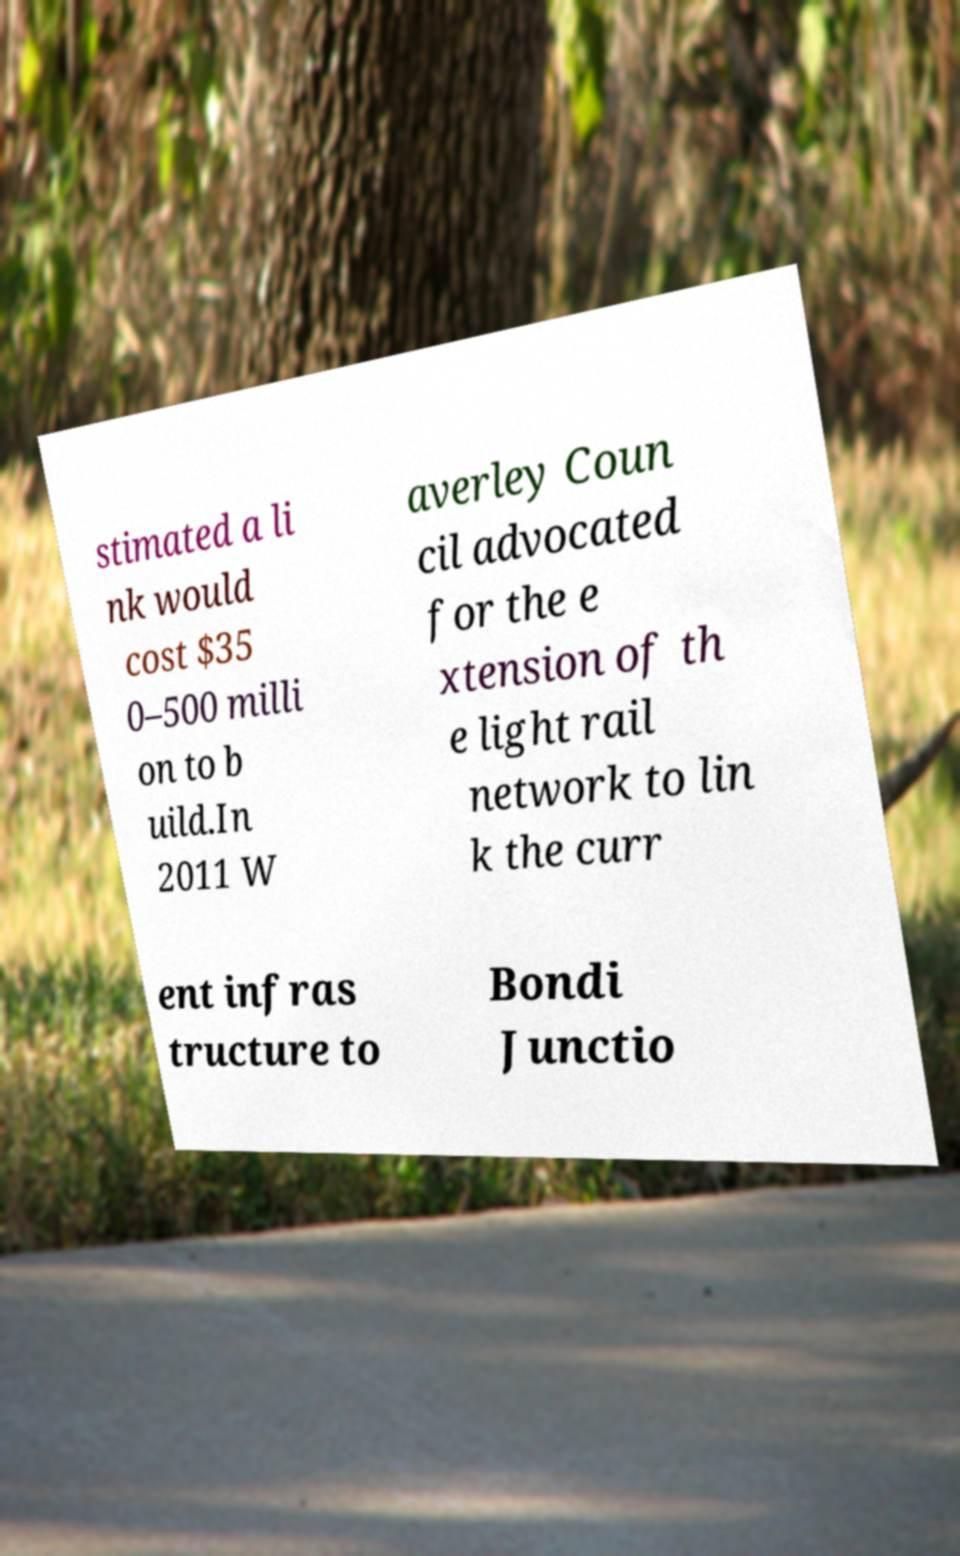Can you read and provide the text displayed in the image?This photo seems to have some interesting text. Can you extract and type it out for me? stimated a li nk would cost $35 0–500 milli on to b uild.In 2011 W averley Coun cil advocated for the e xtension of th e light rail network to lin k the curr ent infras tructure to Bondi Junctio 